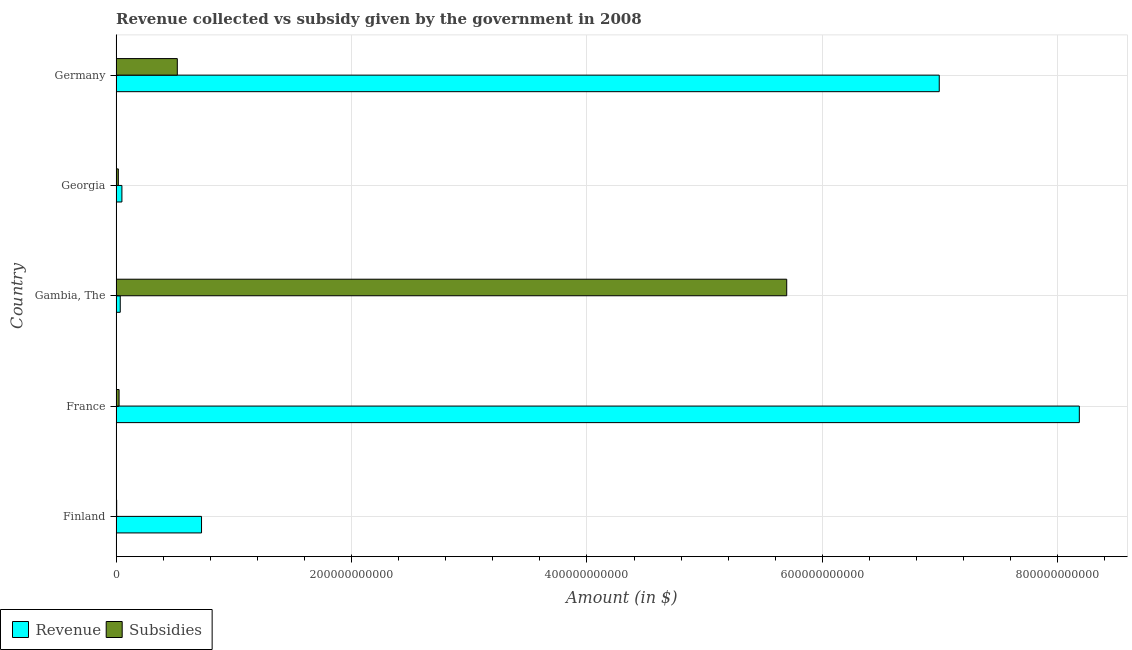How many different coloured bars are there?
Make the answer very short. 2. How many groups of bars are there?
Ensure brevity in your answer.  5. How many bars are there on the 4th tick from the top?
Your response must be concise. 2. How many bars are there on the 5th tick from the bottom?
Keep it short and to the point. 2. In how many cases, is the number of bars for a given country not equal to the number of legend labels?
Provide a short and direct response. 0. What is the amount of revenue collected in France?
Your answer should be compact. 8.18e+11. Across all countries, what is the maximum amount of subsidies given?
Ensure brevity in your answer.  5.70e+11. Across all countries, what is the minimum amount of subsidies given?
Keep it short and to the point. 4.63e+08. In which country was the amount of revenue collected maximum?
Offer a very short reply. France. In which country was the amount of revenue collected minimum?
Make the answer very short. Gambia, The. What is the total amount of revenue collected in the graph?
Keep it short and to the point. 1.60e+12. What is the difference between the amount of subsidies given in France and that in Germany?
Your answer should be compact. -4.95e+1. What is the difference between the amount of subsidies given in Finland and the amount of revenue collected in Germany?
Keep it short and to the point. -6.99e+11. What is the average amount of revenue collected per country?
Offer a terse response. 3.20e+11. What is the difference between the amount of revenue collected and amount of subsidies given in Georgia?
Offer a terse response. 3.03e+09. In how many countries, is the amount of revenue collected greater than 680000000000 $?
Your answer should be compact. 2. What is the ratio of the amount of subsidies given in Finland to that in France?
Offer a very short reply. 0.18. Is the difference between the amount of subsidies given in Finland and Germany greater than the difference between the amount of revenue collected in Finland and Germany?
Provide a succinct answer. Yes. What is the difference between the highest and the second highest amount of revenue collected?
Your answer should be very brief. 1.19e+11. What is the difference between the highest and the lowest amount of revenue collected?
Your answer should be compact. 8.15e+11. In how many countries, is the amount of revenue collected greater than the average amount of revenue collected taken over all countries?
Offer a terse response. 2. What does the 1st bar from the top in Georgia represents?
Your response must be concise. Subsidies. What does the 2nd bar from the bottom in Finland represents?
Offer a very short reply. Subsidies. How many countries are there in the graph?
Offer a very short reply. 5. What is the difference between two consecutive major ticks on the X-axis?
Offer a very short reply. 2.00e+11. Are the values on the major ticks of X-axis written in scientific E-notation?
Offer a terse response. No. Does the graph contain any zero values?
Your response must be concise. No. Does the graph contain grids?
Keep it short and to the point. Yes. Where does the legend appear in the graph?
Offer a terse response. Bottom left. How many legend labels are there?
Give a very brief answer. 2. How are the legend labels stacked?
Give a very brief answer. Horizontal. What is the title of the graph?
Your answer should be compact. Revenue collected vs subsidy given by the government in 2008. What is the label or title of the X-axis?
Make the answer very short. Amount (in $). What is the label or title of the Y-axis?
Make the answer very short. Country. What is the Amount (in $) in Revenue in Finland?
Provide a short and direct response. 7.26e+1. What is the Amount (in $) of Subsidies in Finland?
Keep it short and to the point. 4.63e+08. What is the Amount (in $) of Revenue in France?
Give a very brief answer. 8.18e+11. What is the Amount (in $) in Subsidies in France?
Provide a short and direct response. 2.51e+09. What is the Amount (in $) in Revenue in Gambia, The?
Keep it short and to the point. 3.50e+09. What is the Amount (in $) in Subsidies in Gambia, The?
Give a very brief answer. 5.70e+11. What is the Amount (in $) of Revenue in Georgia?
Give a very brief answer. 4.90e+09. What is the Amount (in $) in Subsidies in Georgia?
Your answer should be compact. 1.87e+09. What is the Amount (in $) of Revenue in Germany?
Your answer should be very brief. 6.99e+11. What is the Amount (in $) of Subsidies in Germany?
Your answer should be compact. 5.20e+1. Across all countries, what is the maximum Amount (in $) in Revenue?
Offer a very short reply. 8.18e+11. Across all countries, what is the maximum Amount (in $) of Subsidies?
Make the answer very short. 5.70e+11. Across all countries, what is the minimum Amount (in $) in Revenue?
Ensure brevity in your answer.  3.50e+09. Across all countries, what is the minimum Amount (in $) in Subsidies?
Ensure brevity in your answer.  4.63e+08. What is the total Amount (in $) of Revenue in the graph?
Your response must be concise. 1.60e+12. What is the total Amount (in $) in Subsidies in the graph?
Your answer should be compact. 6.26e+11. What is the difference between the Amount (in $) in Revenue in Finland and that in France?
Give a very brief answer. -7.46e+11. What is the difference between the Amount (in $) in Subsidies in Finland and that in France?
Provide a succinct answer. -2.04e+09. What is the difference between the Amount (in $) in Revenue in Finland and that in Gambia, The?
Your response must be concise. 6.91e+1. What is the difference between the Amount (in $) of Subsidies in Finland and that in Gambia, The?
Your response must be concise. -5.69e+11. What is the difference between the Amount (in $) of Revenue in Finland and that in Georgia?
Your response must be concise. 6.77e+1. What is the difference between the Amount (in $) in Subsidies in Finland and that in Georgia?
Make the answer very short. -1.41e+09. What is the difference between the Amount (in $) of Revenue in Finland and that in Germany?
Your answer should be compact. -6.27e+11. What is the difference between the Amount (in $) in Subsidies in Finland and that in Germany?
Your response must be concise. -5.15e+1. What is the difference between the Amount (in $) of Revenue in France and that in Gambia, The?
Provide a short and direct response. 8.15e+11. What is the difference between the Amount (in $) in Subsidies in France and that in Gambia, The?
Your answer should be very brief. -5.67e+11. What is the difference between the Amount (in $) of Revenue in France and that in Georgia?
Your answer should be compact. 8.13e+11. What is the difference between the Amount (in $) of Subsidies in France and that in Georgia?
Ensure brevity in your answer.  6.36e+08. What is the difference between the Amount (in $) in Revenue in France and that in Germany?
Offer a terse response. 1.19e+11. What is the difference between the Amount (in $) of Subsidies in France and that in Germany?
Offer a terse response. -4.95e+1. What is the difference between the Amount (in $) in Revenue in Gambia, The and that in Georgia?
Offer a very short reply. -1.40e+09. What is the difference between the Amount (in $) of Subsidies in Gambia, The and that in Georgia?
Provide a short and direct response. 5.68e+11. What is the difference between the Amount (in $) of Revenue in Gambia, The and that in Germany?
Make the answer very short. -6.96e+11. What is the difference between the Amount (in $) of Subsidies in Gambia, The and that in Germany?
Your answer should be very brief. 5.18e+11. What is the difference between the Amount (in $) of Revenue in Georgia and that in Germany?
Ensure brevity in your answer.  -6.94e+11. What is the difference between the Amount (in $) in Subsidies in Georgia and that in Germany?
Offer a very short reply. -5.01e+1. What is the difference between the Amount (in $) in Revenue in Finland and the Amount (in $) in Subsidies in France?
Ensure brevity in your answer.  7.00e+1. What is the difference between the Amount (in $) of Revenue in Finland and the Amount (in $) of Subsidies in Gambia, The?
Your response must be concise. -4.97e+11. What is the difference between the Amount (in $) of Revenue in Finland and the Amount (in $) of Subsidies in Georgia?
Provide a succinct answer. 7.07e+1. What is the difference between the Amount (in $) of Revenue in Finland and the Amount (in $) of Subsidies in Germany?
Give a very brief answer. 2.06e+1. What is the difference between the Amount (in $) of Revenue in France and the Amount (in $) of Subsidies in Gambia, The?
Keep it short and to the point. 2.49e+11. What is the difference between the Amount (in $) in Revenue in France and the Amount (in $) in Subsidies in Georgia?
Your answer should be very brief. 8.16e+11. What is the difference between the Amount (in $) in Revenue in France and the Amount (in $) in Subsidies in Germany?
Your response must be concise. 7.66e+11. What is the difference between the Amount (in $) of Revenue in Gambia, The and the Amount (in $) of Subsidies in Georgia?
Your answer should be very brief. 1.63e+09. What is the difference between the Amount (in $) in Revenue in Gambia, The and the Amount (in $) in Subsidies in Germany?
Ensure brevity in your answer.  -4.85e+1. What is the difference between the Amount (in $) in Revenue in Georgia and the Amount (in $) in Subsidies in Germany?
Provide a short and direct response. -4.71e+1. What is the average Amount (in $) of Revenue per country?
Give a very brief answer. 3.20e+11. What is the average Amount (in $) in Subsidies per country?
Your answer should be very brief. 1.25e+11. What is the difference between the Amount (in $) of Revenue and Amount (in $) of Subsidies in Finland?
Offer a very short reply. 7.21e+1. What is the difference between the Amount (in $) in Revenue and Amount (in $) in Subsidies in France?
Keep it short and to the point. 8.16e+11. What is the difference between the Amount (in $) of Revenue and Amount (in $) of Subsidies in Gambia, The?
Your response must be concise. -5.66e+11. What is the difference between the Amount (in $) of Revenue and Amount (in $) of Subsidies in Georgia?
Provide a short and direct response. 3.03e+09. What is the difference between the Amount (in $) of Revenue and Amount (in $) of Subsidies in Germany?
Provide a succinct answer. 6.47e+11. What is the ratio of the Amount (in $) in Revenue in Finland to that in France?
Make the answer very short. 0.09. What is the ratio of the Amount (in $) in Subsidies in Finland to that in France?
Provide a short and direct response. 0.18. What is the ratio of the Amount (in $) of Revenue in Finland to that in Gambia, The?
Offer a very short reply. 20.73. What is the ratio of the Amount (in $) of Subsidies in Finland to that in Gambia, The?
Provide a succinct answer. 0. What is the ratio of the Amount (in $) of Revenue in Finland to that in Georgia?
Provide a short and direct response. 14.8. What is the ratio of the Amount (in $) in Subsidies in Finland to that in Georgia?
Offer a very short reply. 0.25. What is the ratio of the Amount (in $) of Revenue in Finland to that in Germany?
Offer a very short reply. 0.1. What is the ratio of the Amount (in $) in Subsidies in Finland to that in Germany?
Provide a short and direct response. 0.01. What is the ratio of the Amount (in $) of Revenue in France to that in Gambia, The?
Provide a short and direct response. 233.79. What is the ratio of the Amount (in $) in Subsidies in France to that in Gambia, The?
Give a very brief answer. 0. What is the ratio of the Amount (in $) of Revenue in France to that in Georgia?
Offer a terse response. 166.97. What is the ratio of the Amount (in $) of Subsidies in France to that in Georgia?
Your answer should be very brief. 1.34. What is the ratio of the Amount (in $) of Revenue in France to that in Germany?
Offer a very short reply. 1.17. What is the ratio of the Amount (in $) of Subsidies in France to that in Germany?
Offer a very short reply. 0.05. What is the ratio of the Amount (in $) of Revenue in Gambia, The to that in Georgia?
Your answer should be very brief. 0.71. What is the ratio of the Amount (in $) in Subsidies in Gambia, The to that in Georgia?
Give a very brief answer. 304.38. What is the ratio of the Amount (in $) in Revenue in Gambia, The to that in Germany?
Provide a short and direct response. 0.01. What is the ratio of the Amount (in $) in Subsidies in Gambia, The to that in Germany?
Offer a terse response. 10.96. What is the ratio of the Amount (in $) in Revenue in Georgia to that in Germany?
Keep it short and to the point. 0.01. What is the ratio of the Amount (in $) of Subsidies in Georgia to that in Germany?
Your response must be concise. 0.04. What is the difference between the highest and the second highest Amount (in $) in Revenue?
Your answer should be compact. 1.19e+11. What is the difference between the highest and the second highest Amount (in $) of Subsidies?
Your response must be concise. 5.18e+11. What is the difference between the highest and the lowest Amount (in $) of Revenue?
Keep it short and to the point. 8.15e+11. What is the difference between the highest and the lowest Amount (in $) of Subsidies?
Make the answer very short. 5.69e+11. 